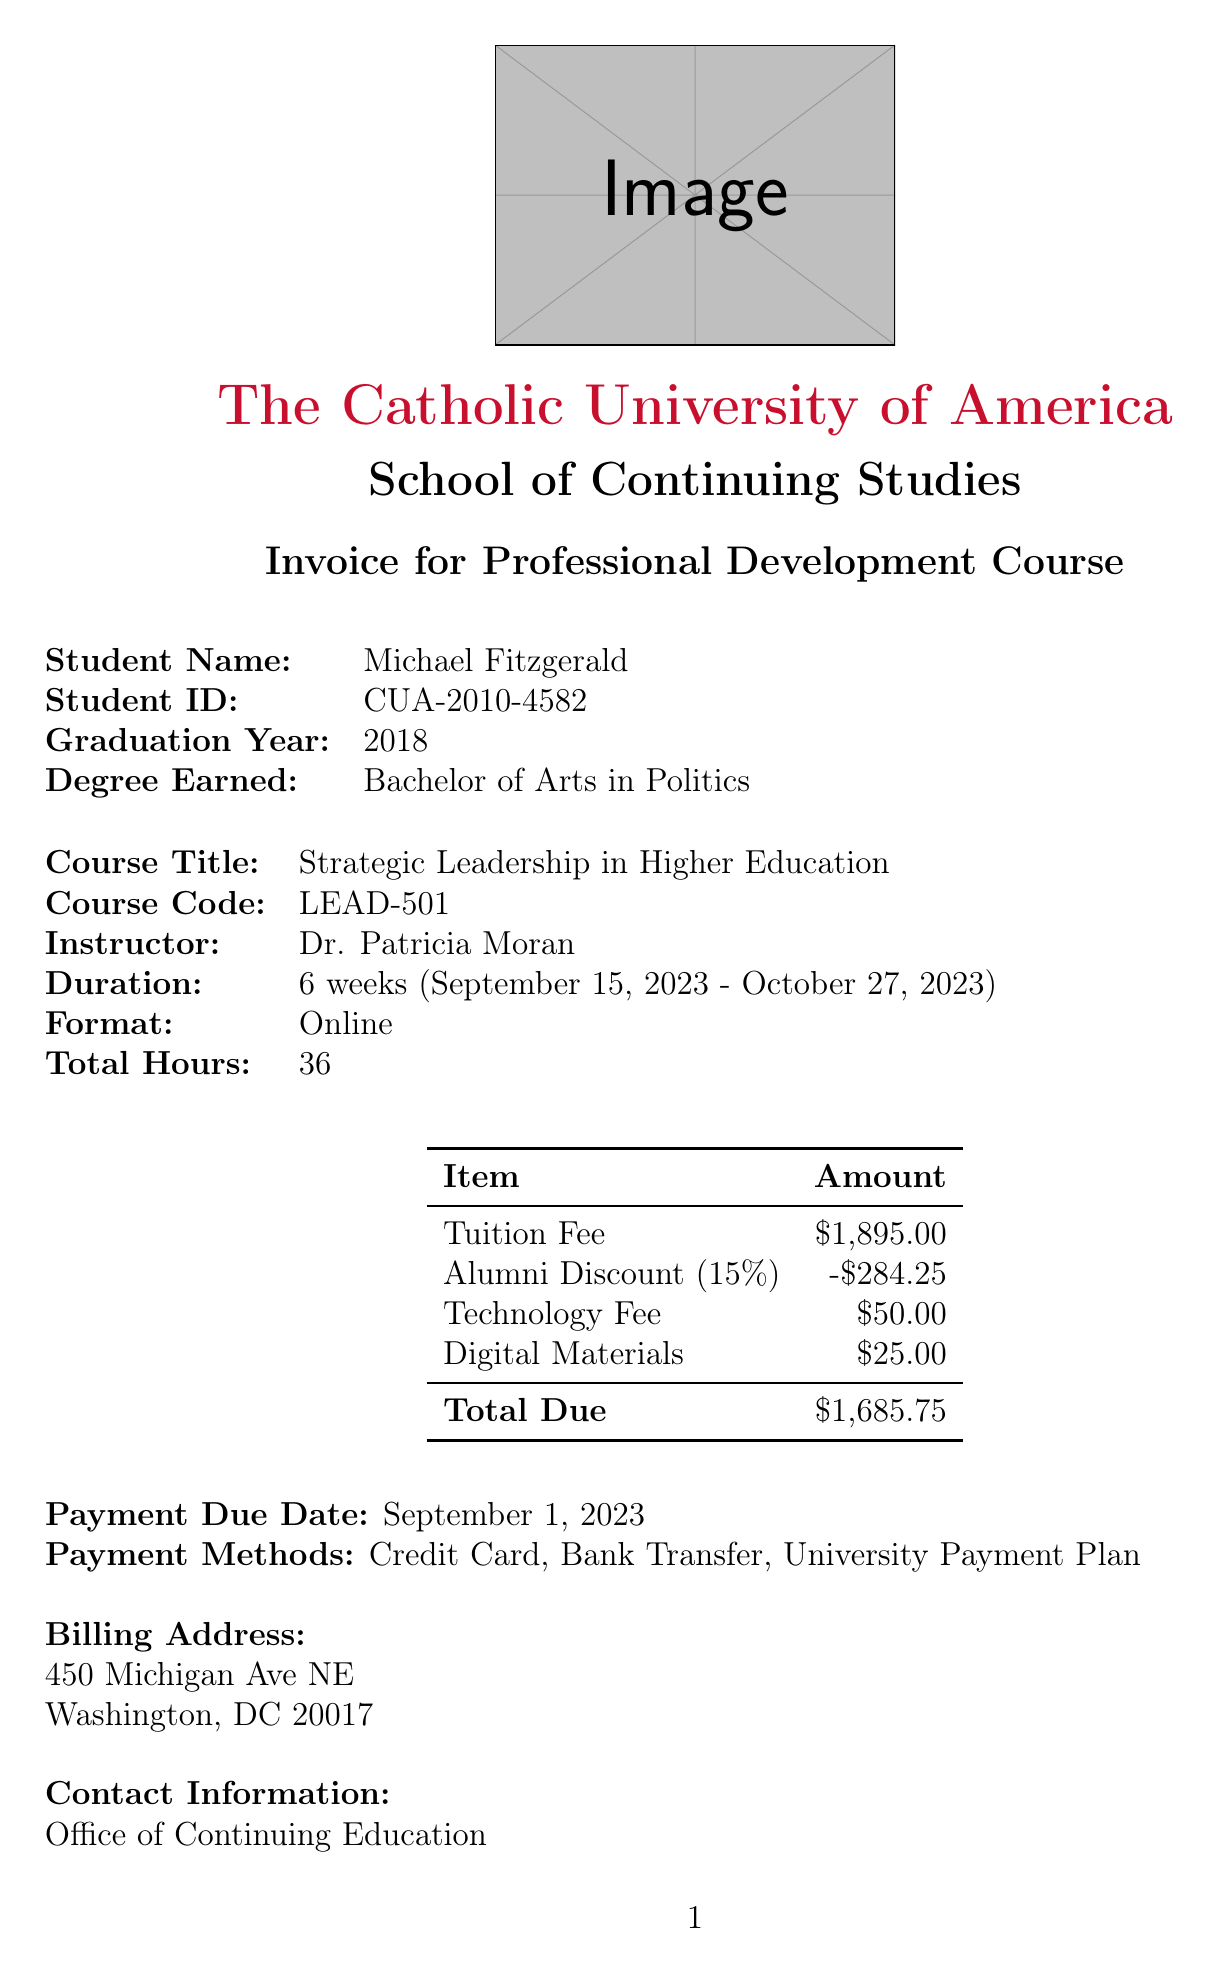What is the course title? The course title is specified in the document under "Course Title."
Answer: Strategic Leadership in Higher Education What is the total tuition fee? The total tuition fee is listed in the payment breakdown section of the document.
Answer: $1,895.00 Who is the instructor for the course? The instructor's name is mentioned in the course details section.
Answer: Dr. Patricia Moran What is the deadline for payment? The payment due date is explicitly stated in the document.
Answer: September 1, 2023 What is the alumni discount percentage? The alumni discount percentage is provided in the payment breakdown details.
Answer: 15% What is the duration of the course? The duration of the course is indicated in the course details section.
Answer: 6 weeks What is the total amount due after the alumni discount? The total amount due is calculated after subtracting the alumni discount and adding fees.
Answer: $1,685.75 What are the payment methods available? The document lists the methods available for payment in a dedicated section.
Answer: Credit Card, Bank Transfer, University Payment Plan What is the cancellation policy? The cancellation policy outlines the refund conditions associated with course cancellation.
Answer: Full refund if cancelled 14 days before the start date. 50% refund if cancelled 7-13 days before the start date. No refund for cancellations less than 7 days before the start date 